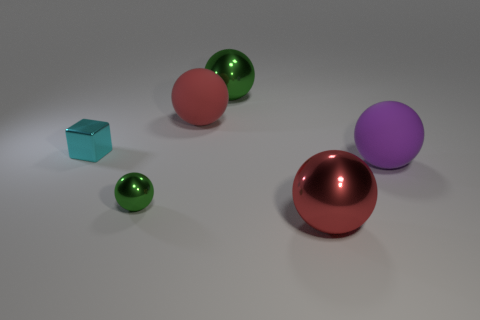Are there fewer red balls that are on the left side of the tiny cyan cube than metallic balls in front of the purple matte ball?
Your answer should be very brief. Yes. How many other things are there of the same material as the big purple object?
Provide a succinct answer. 1. There is a green thing that is the same size as the cyan thing; what is its material?
Give a very brief answer. Metal. Are there fewer large red matte balls in front of the small cyan cube than big red objects?
Provide a succinct answer. Yes. There is a big matte thing that is on the right side of the green shiny object that is on the right side of the red thing behind the metallic block; what is its shape?
Offer a terse response. Sphere. What size is the shiny ball behind the large purple thing?
Keep it short and to the point. Large. There is a purple rubber object that is the same size as the red metal thing; what is its shape?
Ensure brevity in your answer.  Sphere. What number of things are blue spheres or metallic spheres in front of the large purple object?
Keep it short and to the point. 2. How many red balls are behind the green sphere in front of the matte object that is behind the small block?
Offer a terse response. 1. The tiny ball that is made of the same material as the cyan block is what color?
Your response must be concise. Green. 